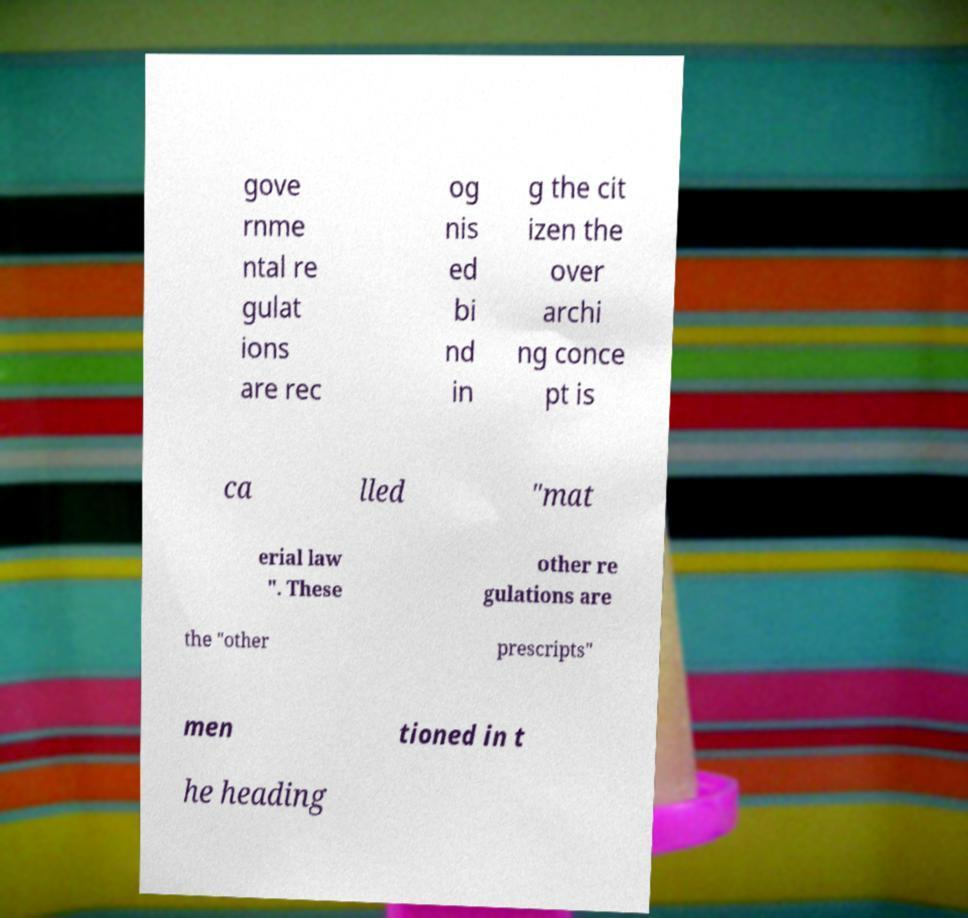Can you read and provide the text displayed in the image?This photo seems to have some interesting text. Can you extract and type it out for me? gove rnme ntal re gulat ions are rec og nis ed bi nd in g the cit izen the over archi ng conce pt is ca lled "mat erial law ". These other re gulations are the "other prescripts" men tioned in t he heading 